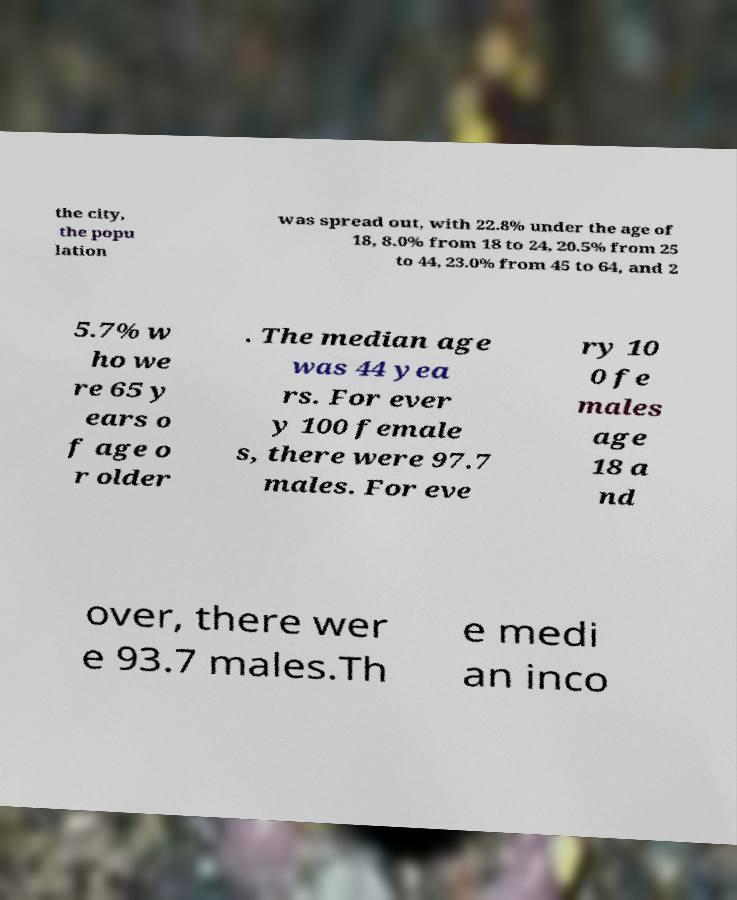Can you read and provide the text displayed in the image?This photo seems to have some interesting text. Can you extract and type it out for me? the city, the popu lation was spread out, with 22.8% under the age of 18, 8.0% from 18 to 24, 20.5% from 25 to 44, 23.0% from 45 to 64, and 2 5.7% w ho we re 65 y ears o f age o r older . The median age was 44 yea rs. For ever y 100 female s, there were 97.7 males. For eve ry 10 0 fe males age 18 a nd over, there wer e 93.7 males.Th e medi an inco 